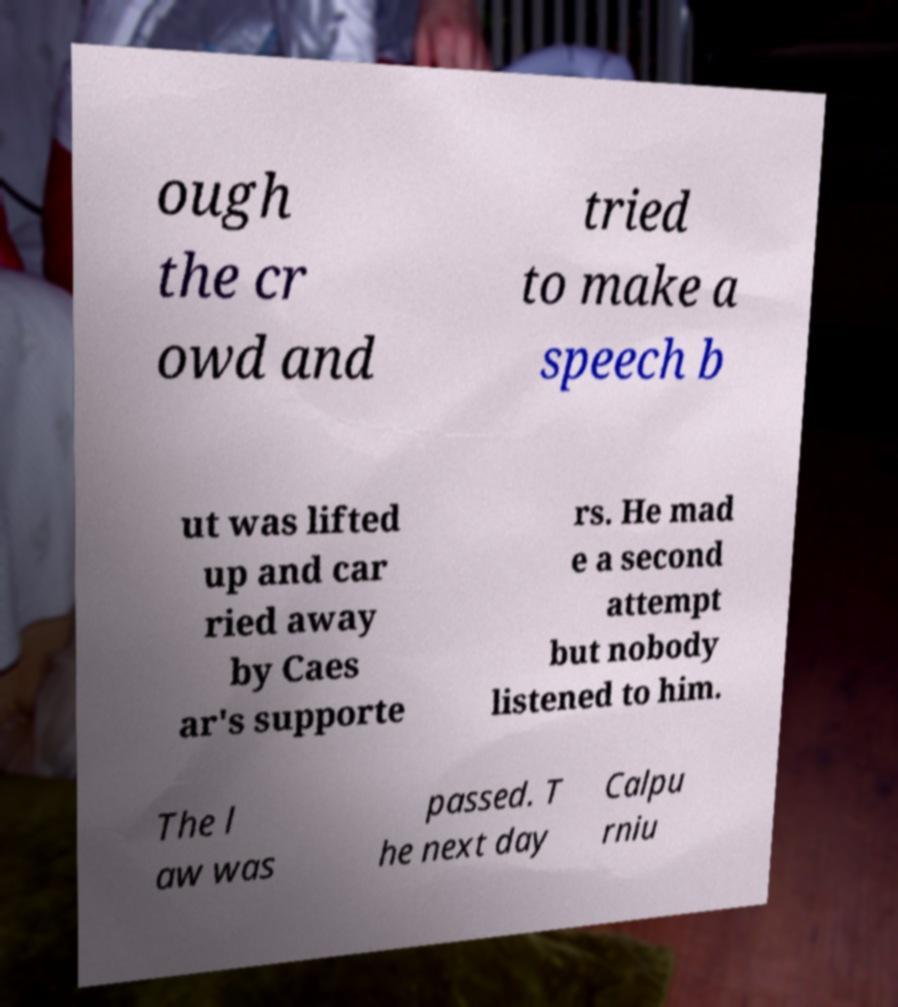Can you accurately transcribe the text from the provided image for me? ough the cr owd and tried to make a speech b ut was lifted up and car ried away by Caes ar's supporte rs. He mad e a second attempt but nobody listened to him. The l aw was passed. T he next day Calpu rniu 